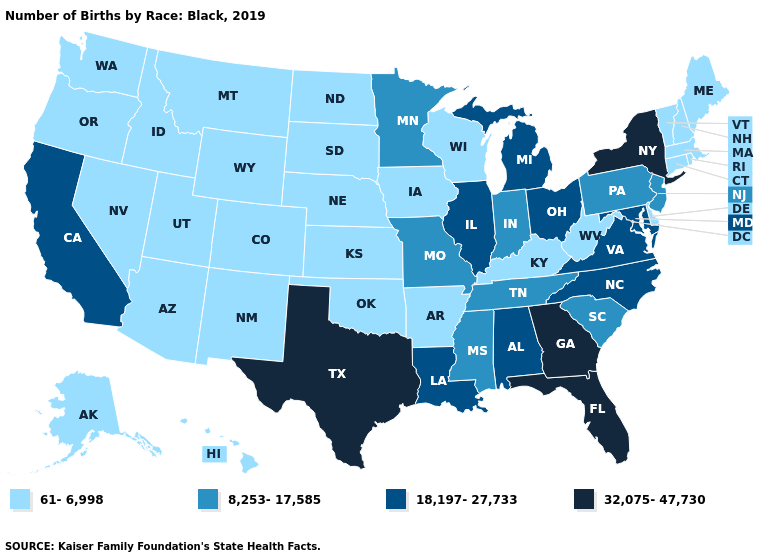Does the first symbol in the legend represent the smallest category?
Short answer required. Yes. Name the states that have a value in the range 61-6,998?
Answer briefly. Alaska, Arizona, Arkansas, Colorado, Connecticut, Delaware, Hawaii, Idaho, Iowa, Kansas, Kentucky, Maine, Massachusetts, Montana, Nebraska, Nevada, New Hampshire, New Mexico, North Dakota, Oklahoma, Oregon, Rhode Island, South Dakota, Utah, Vermont, Washington, West Virginia, Wisconsin, Wyoming. Name the states that have a value in the range 18,197-27,733?
Write a very short answer. Alabama, California, Illinois, Louisiana, Maryland, Michigan, North Carolina, Ohio, Virginia. Does Arkansas have the same value as Alaska?
Write a very short answer. Yes. What is the highest value in the USA?
Quick response, please. 32,075-47,730. What is the value of Vermont?
Write a very short answer. 61-6,998. What is the value of North Dakota?
Quick response, please. 61-6,998. Does Ohio have the lowest value in the MidWest?
Write a very short answer. No. Name the states that have a value in the range 8,253-17,585?
Keep it brief. Indiana, Minnesota, Mississippi, Missouri, New Jersey, Pennsylvania, South Carolina, Tennessee. Name the states that have a value in the range 18,197-27,733?
Give a very brief answer. Alabama, California, Illinois, Louisiana, Maryland, Michigan, North Carolina, Ohio, Virginia. Does Wisconsin have the lowest value in the MidWest?
Quick response, please. Yes. What is the value of Alaska?
Answer briefly. 61-6,998. What is the value of Washington?
Short answer required. 61-6,998. Name the states that have a value in the range 8,253-17,585?
Quick response, please. Indiana, Minnesota, Mississippi, Missouri, New Jersey, Pennsylvania, South Carolina, Tennessee. Among the states that border Wyoming , which have the highest value?
Answer briefly. Colorado, Idaho, Montana, Nebraska, South Dakota, Utah. 